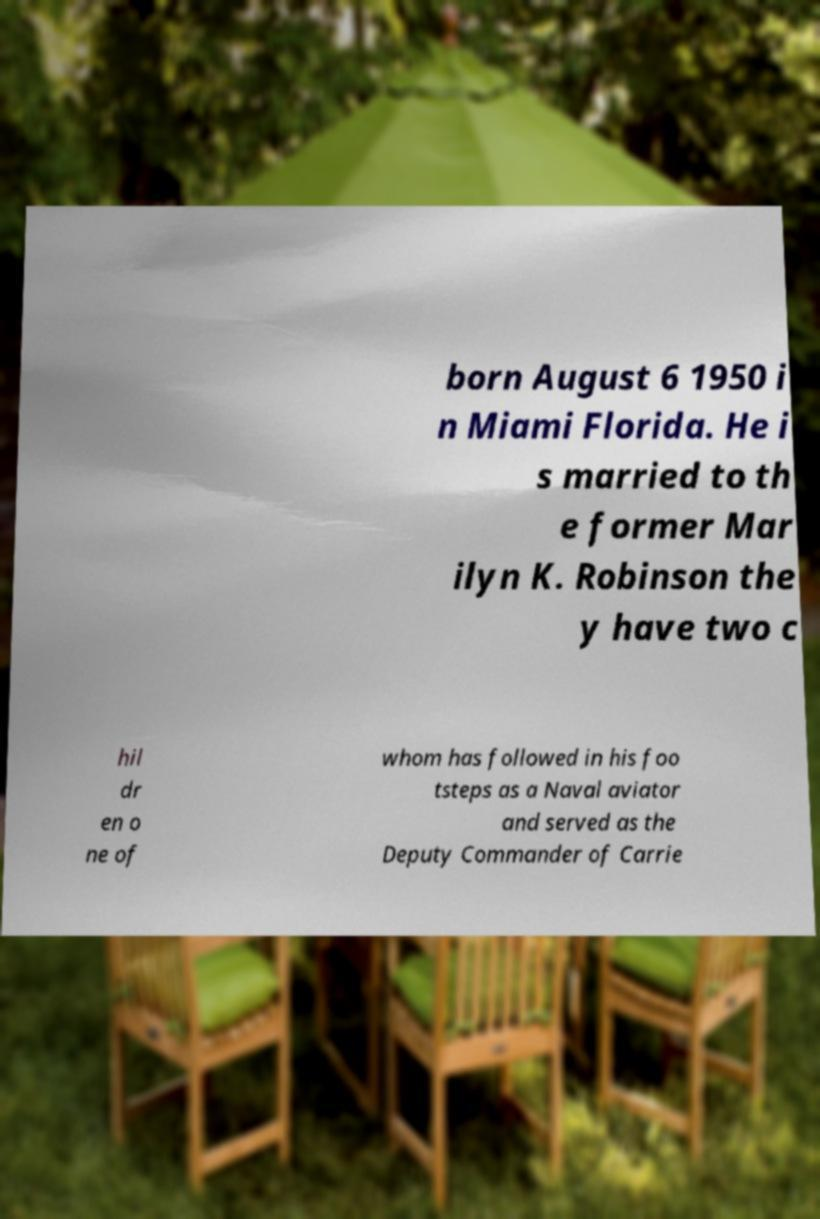Could you assist in decoding the text presented in this image and type it out clearly? born August 6 1950 i n Miami Florida. He i s married to th e former Mar ilyn K. Robinson the y have two c hil dr en o ne of whom has followed in his foo tsteps as a Naval aviator and served as the Deputy Commander of Carrie 